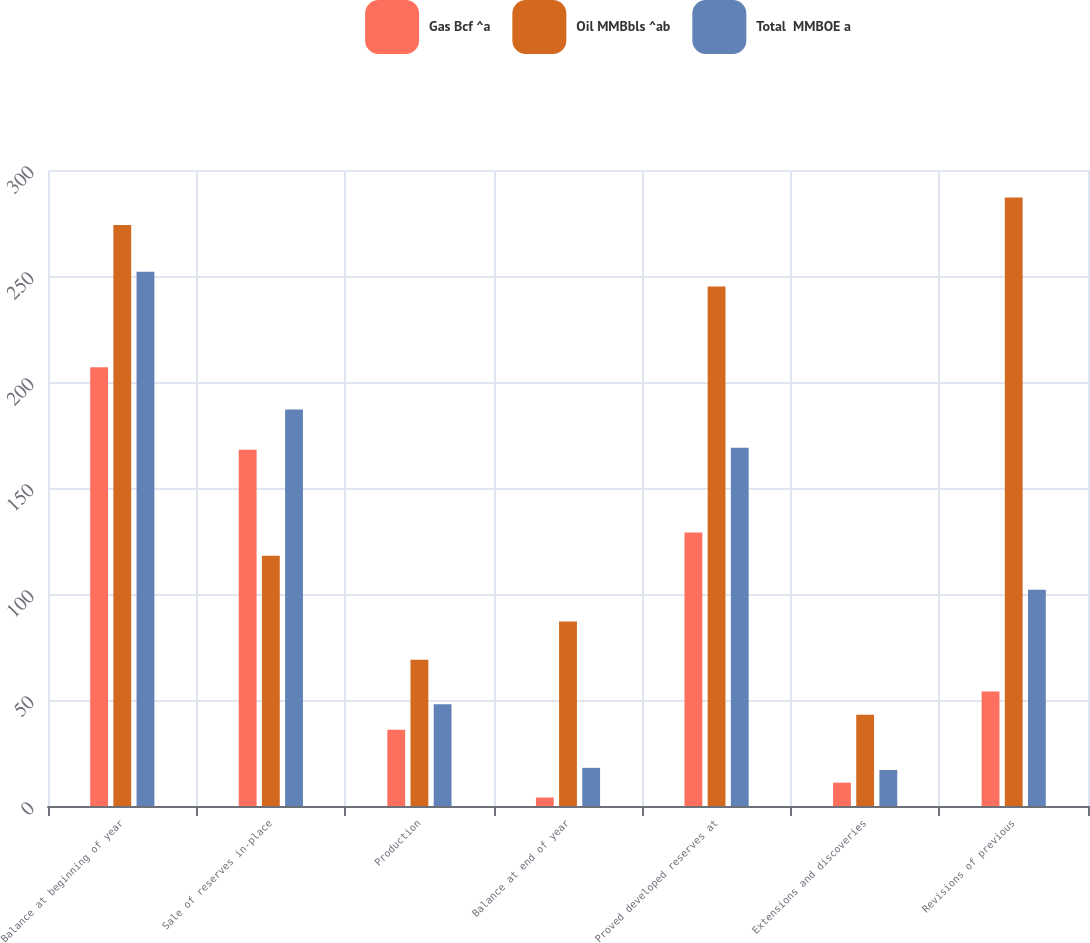Convert chart to OTSL. <chart><loc_0><loc_0><loc_500><loc_500><stacked_bar_chart><ecel><fcel>Balance at beginning of year<fcel>Sale of reserves in-place<fcel>Production<fcel>Balance at end of year<fcel>Proved developed reserves at<fcel>Extensions and discoveries<fcel>Revisions of previous<nl><fcel>Gas Bcf ^a<fcel>207<fcel>168<fcel>36<fcel>4<fcel>129<fcel>11<fcel>54<nl><fcel>Oil MMBbls ^ab<fcel>274<fcel>118<fcel>69<fcel>87<fcel>245<fcel>43<fcel>287<nl><fcel>Total  MMBOE a<fcel>252<fcel>187<fcel>48<fcel>18<fcel>169<fcel>17<fcel>102<nl></chart> 